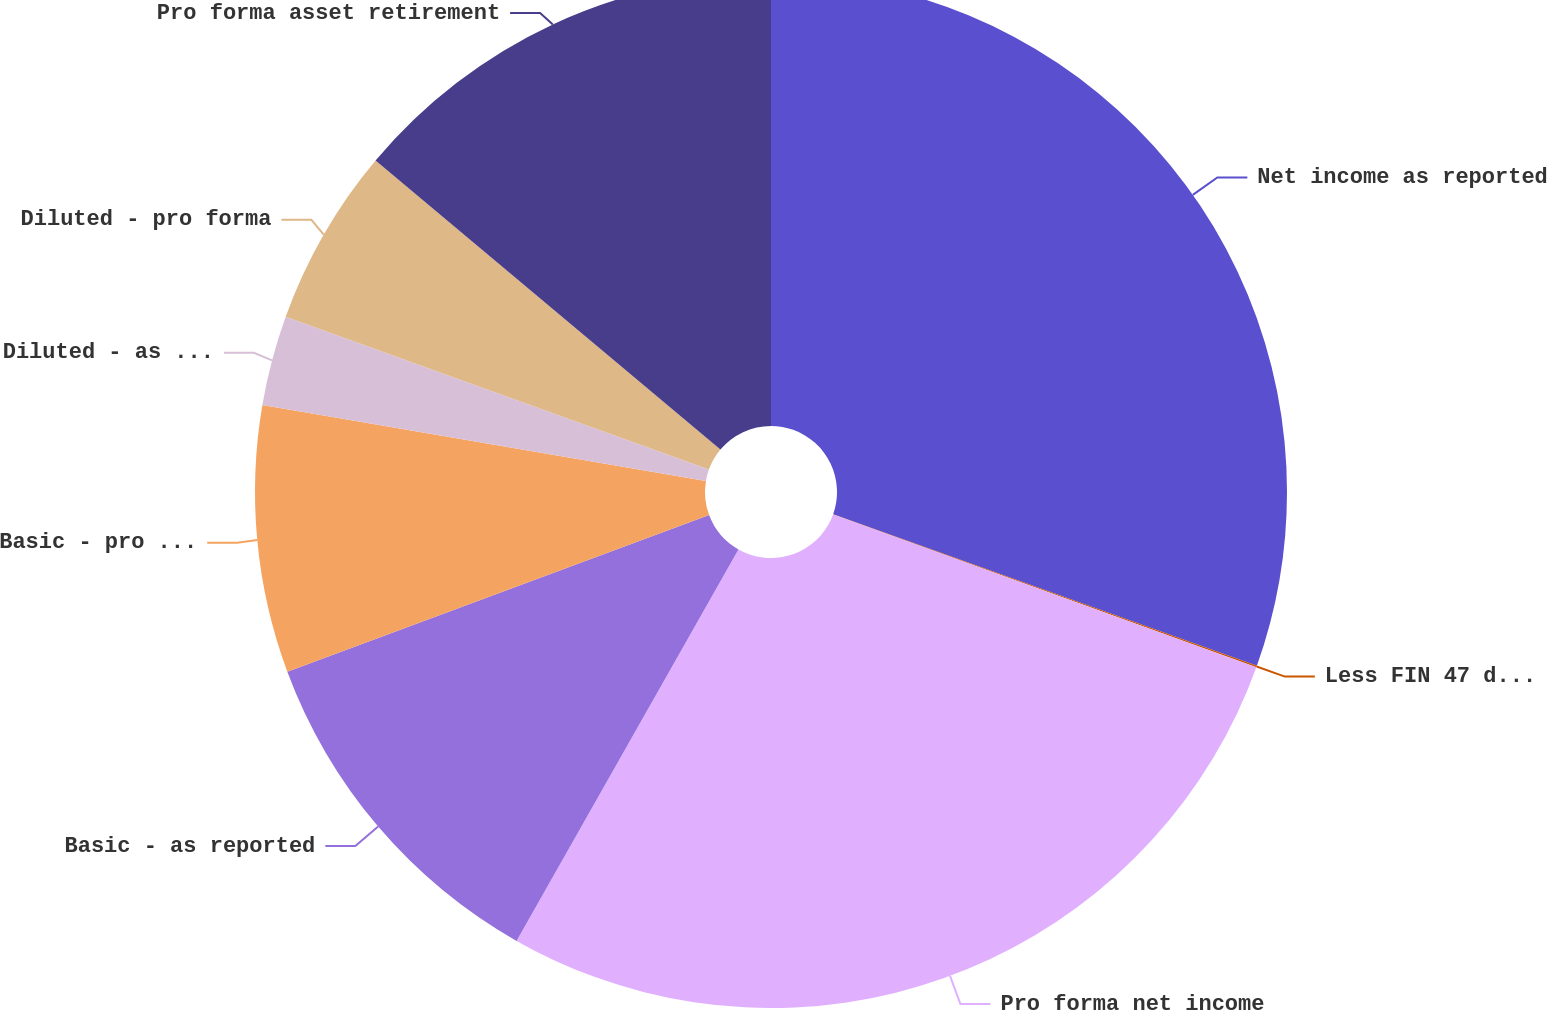Convert chart. <chart><loc_0><loc_0><loc_500><loc_500><pie_chart><fcel>Net income as reported<fcel>Less FIN 47 depreciation and<fcel>Pro forma net income<fcel>Basic - as reported<fcel>Basic - pro forma<fcel>Diluted - as reported<fcel>Diluted - pro forma<fcel>Pro forma asset retirement<nl><fcel>30.47%<fcel>0.05%<fcel>27.7%<fcel>11.13%<fcel>8.36%<fcel>2.82%<fcel>5.59%<fcel>13.9%<nl></chart> 